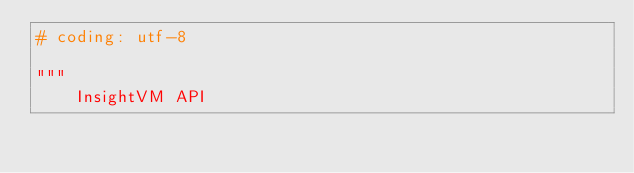Convert code to text. <code><loc_0><loc_0><loc_500><loc_500><_Python_># coding: utf-8

"""
    InsightVM API
</code> 